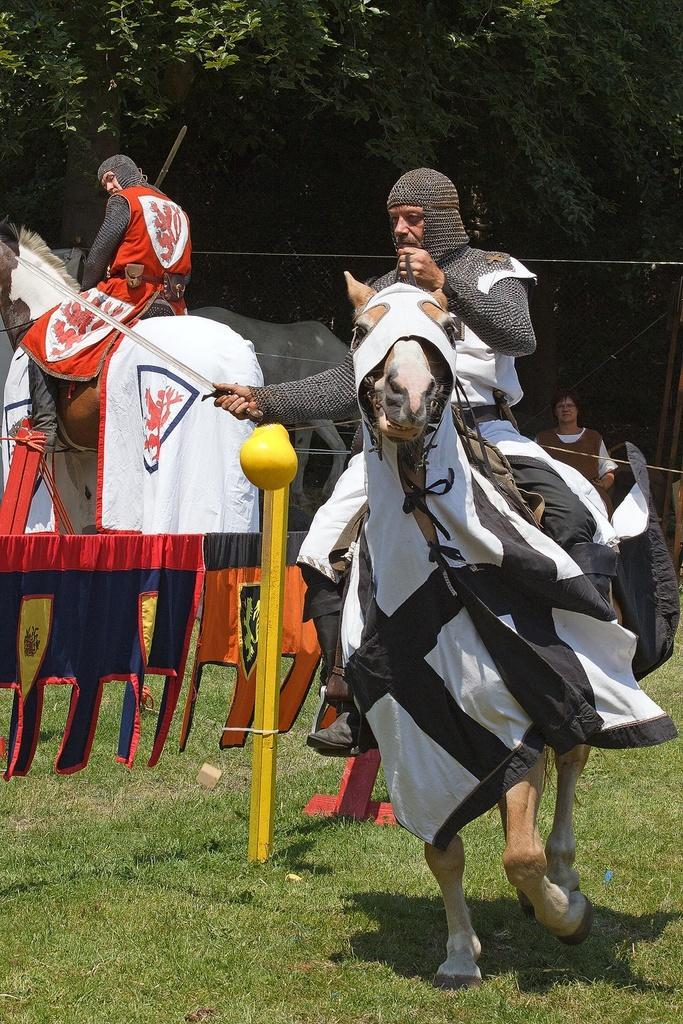Could you give a brief overview of what you see in this image? This person sitting and riding horse and holding sword and we can see yellow pole,grass and colorful clothes. In the background there is a person sitting on horse and we can see a man and trees. 